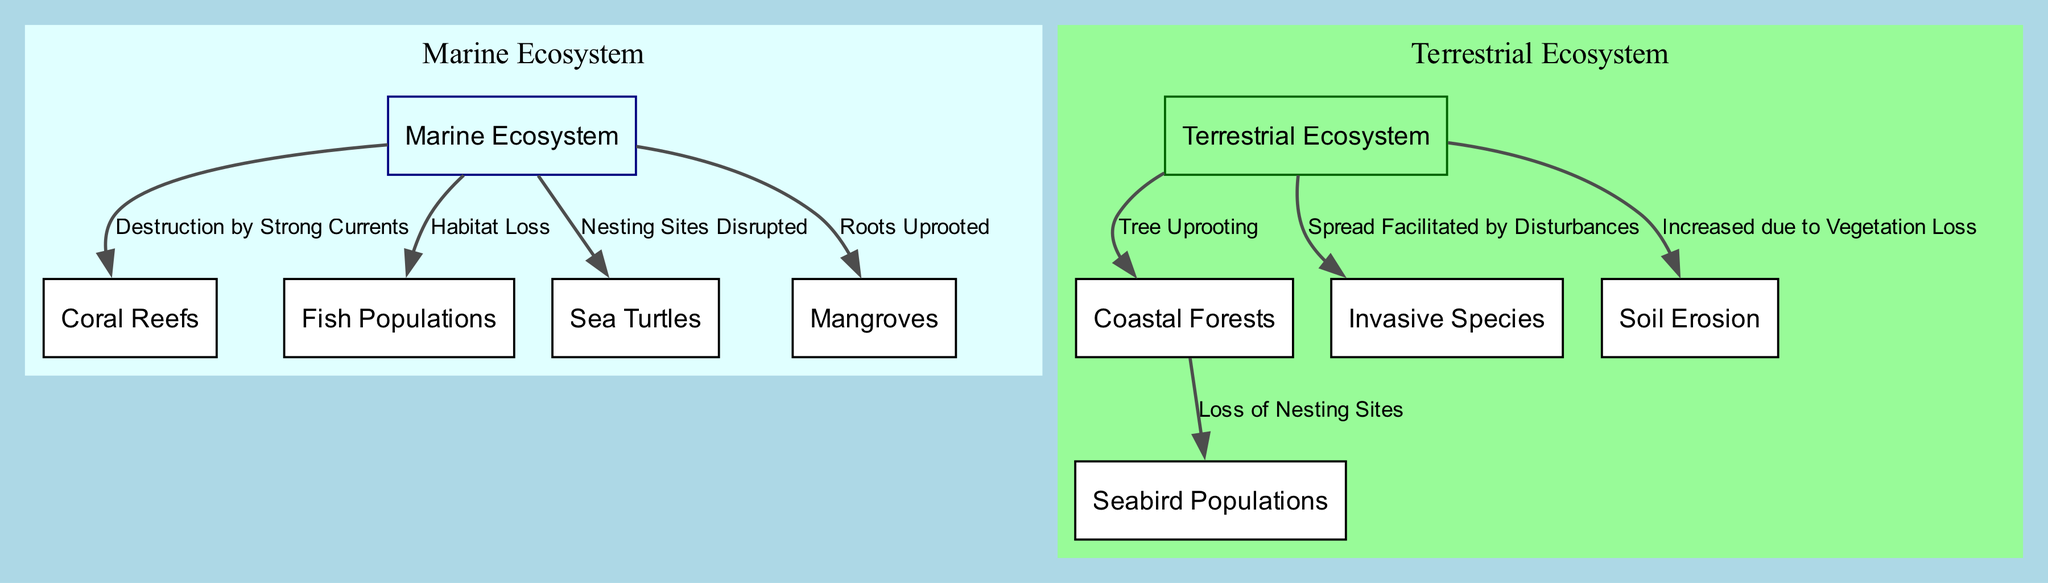What is the total number of nodes in the diagram? Counting the nodes listed, there are 10 distinct nodes comprising both marine and terrestrial ecosystems.
Answer: 10 What type of ecosystem is indicated by the label 'coral reefs'? The label 'coral reefs' falls under the category of the marine ecosystem as shown in the diagram.
Answer: Marine Ecosystem Which edge describes the impact of hurricanes on fish populations? The edge connects 'marine_ecosystem' to 'fish_populations' and indicates 'Habitat Loss', which directly describes the impact.
Answer: Habitat Loss What are the two main ecosystems represented in this diagram? The diagram clearly distinguishes between 'Marine Ecosystem' and 'Terrestrial Ecosystem', as shown in the clustered visuals.
Answer: Marine Ecosystem and Terrestrial Ecosystem Which factor contributes to soil erosion as per the diagram? According to the edge labeled 'Increased due to Vegetation Loss', soil erosion is caused by the loss of vegetation in the terrestrial ecosystem.
Answer: Increased due to Vegetation Loss How do invasive species spread according to the diagram? The diagram indicates that 'Spread Facilitated by Disturbances' leads to the spread of invasive species after hurricanes affect the ecosystems.
Answer: Spread Facilitated by Disturbances Which group of animals is impacted by 'Loss of Nesting Sites'? The edge leads from 'coastal_forests' to 'seabird_populations', indicating that seabirds are affected by the loss of their nesting sites.
Answer: Seabird Populations What cause is attributed to the uprooting of mangroves? The edge indicates that 'Roots Uprooted' is the result of the disturbances caused by hurricanes in the marine ecosystem.
Answer: Roots Uprooted What relationship does 'tree uprooting' have with the terrestrial ecosystem? The edge states that 'Tree Uprooting' directly impacts the 'coastal_forests' under the terrestrial ecosystem, showing a clear relationship.
Answer: Tree Uprooting 